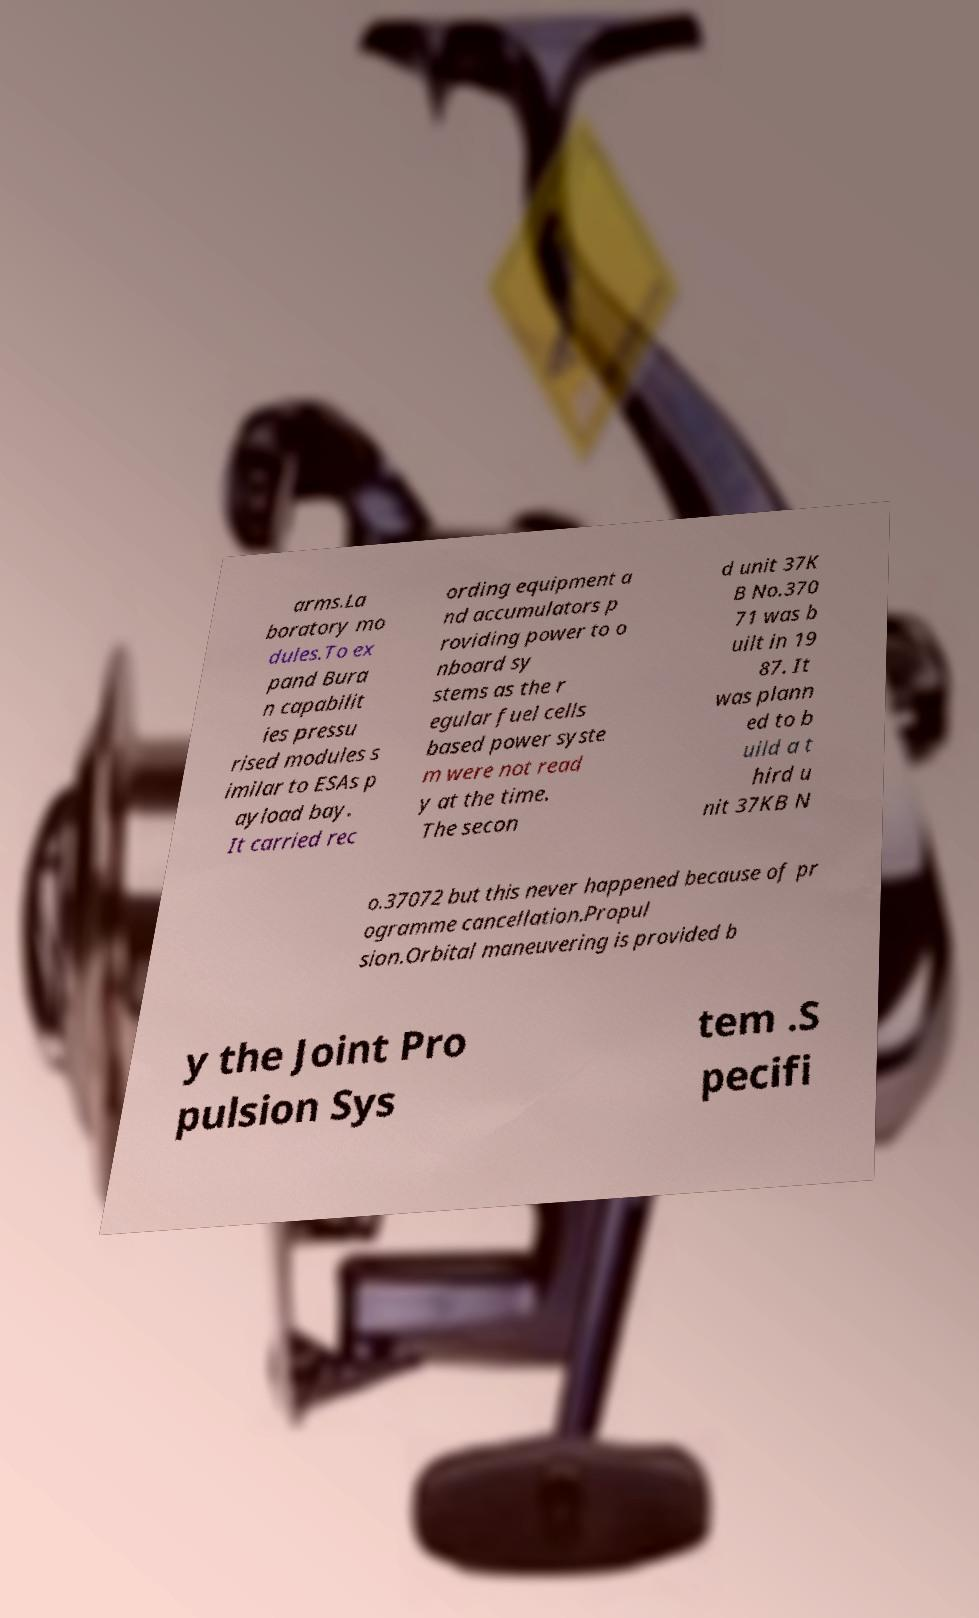Could you assist in decoding the text presented in this image and type it out clearly? arms.La boratory mo dules.To ex pand Bura n capabilit ies pressu rised modules s imilar to ESAs p ayload bay. It carried rec ording equipment a nd accumulators p roviding power to o nboard sy stems as the r egular fuel cells based power syste m were not read y at the time. The secon d unit 37K B No.370 71 was b uilt in 19 87. It was plann ed to b uild a t hird u nit 37KB N o.37072 but this never happened because of pr ogramme cancellation.Propul sion.Orbital maneuvering is provided b y the Joint Pro pulsion Sys tem .S pecifi 